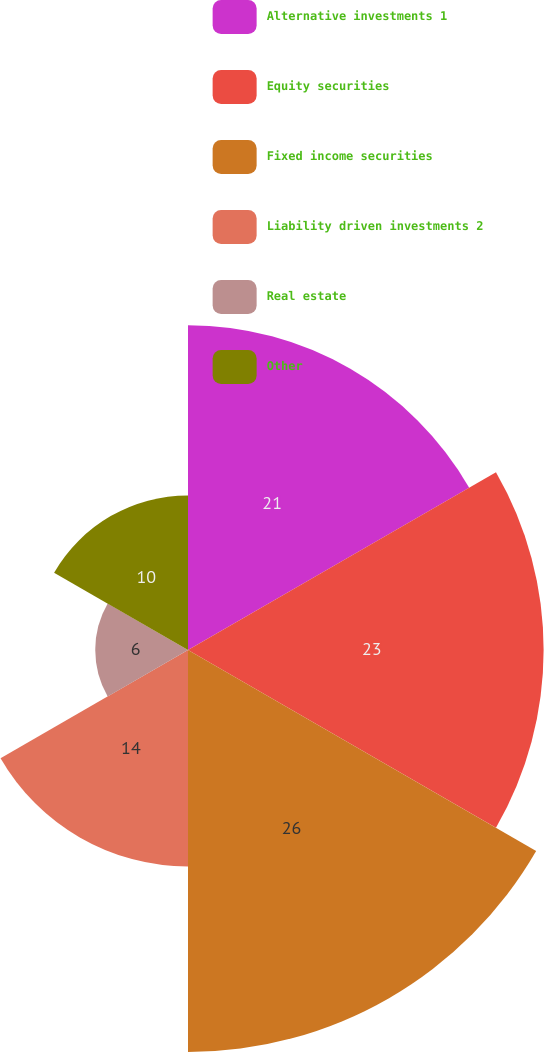Convert chart. <chart><loc_0><loc_0><loc_500><loc_500><pie_chart><fcel>Alternative investments 1<fcel>Equity securities<fcel>Fixed income securities<fcel>Liability driven investments 2<fcel>Real estate<fcel>Other<nl><fcel>21.0%<fcel>23.0%<fcel>26.0%<fcel>14.0%<fcel>6.0%<fcel>10.0%<nl></chart> 